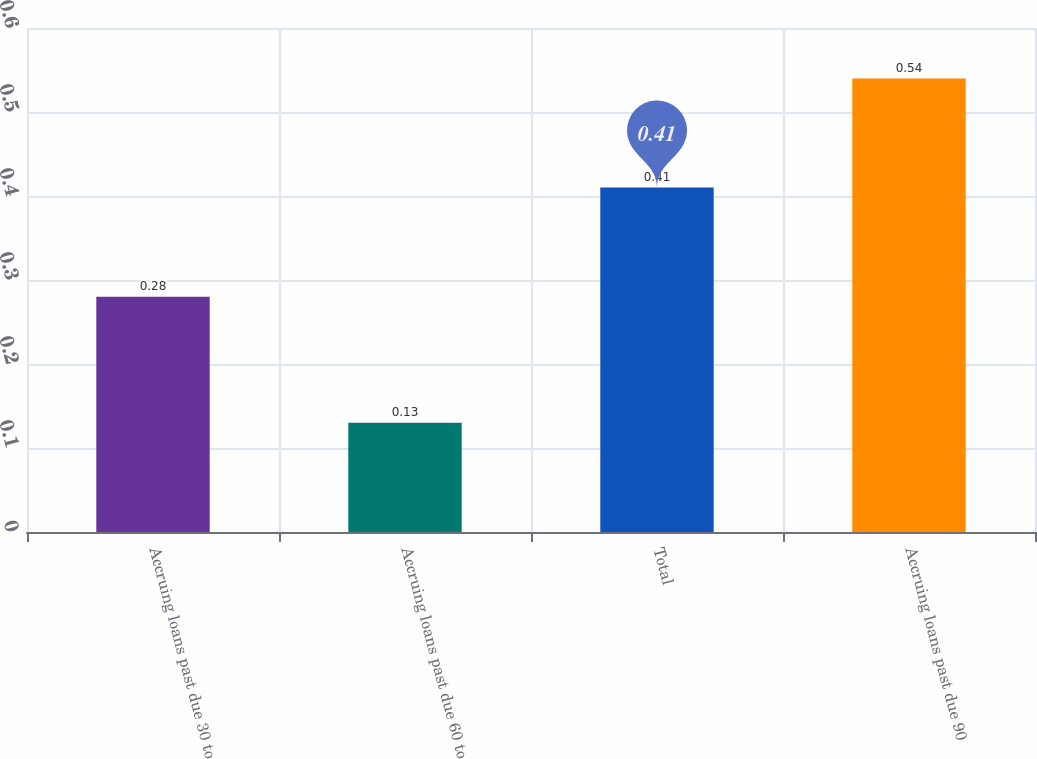Convert chart to OTSL. <chart><loc_0><loc_0><loc_500><loc_500><bar_chart><fcel>Accruing loans past due 30 to<fcel>Accruing loans past due 60 to<fcel>Total<fcel>Accruing loans past due 90<nl><fcel>0.28<fcel>0.13<fcel>0.41<fcel>0.54<nl></chart> 